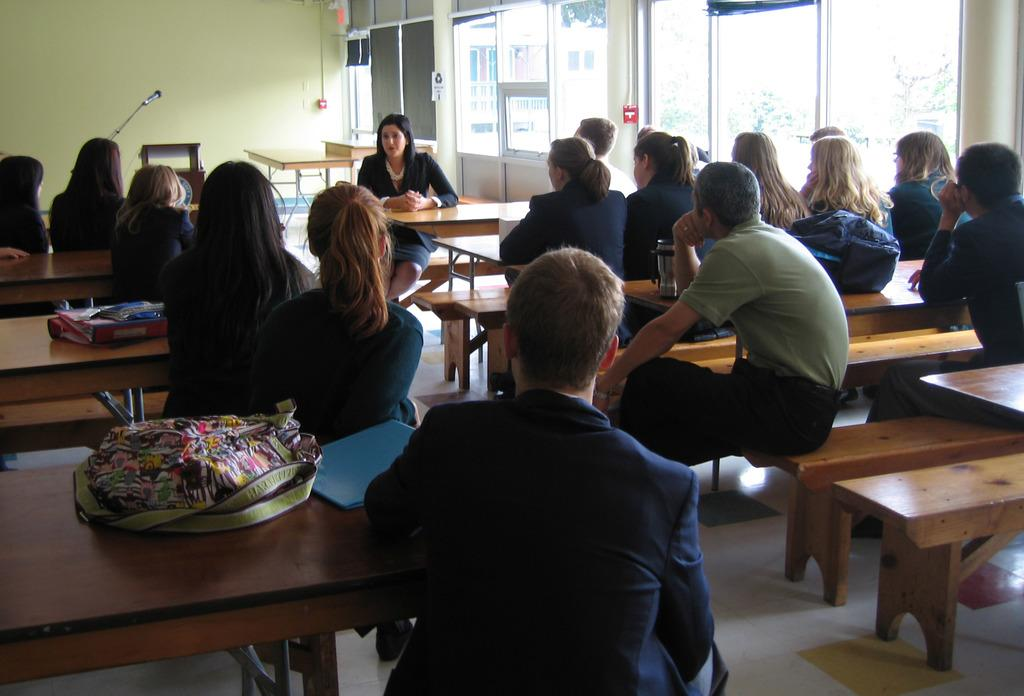What are the people in the image doing? There are persons sitting on a bench in the image. What objects are on the bench with the people? There are two bags on the bench. What can be seen in the background of the image? There is a wall in the background of the image. What object is located at the right side of the image? There is a microphone at the right side of the image. Is there any opening in the wall visible in the image? Yes, there is a window in the image. What type of ink is being used to write on the person's mind in the image? There is no mention of ink or writing on a person's mind in the image; these concepts are not present. 